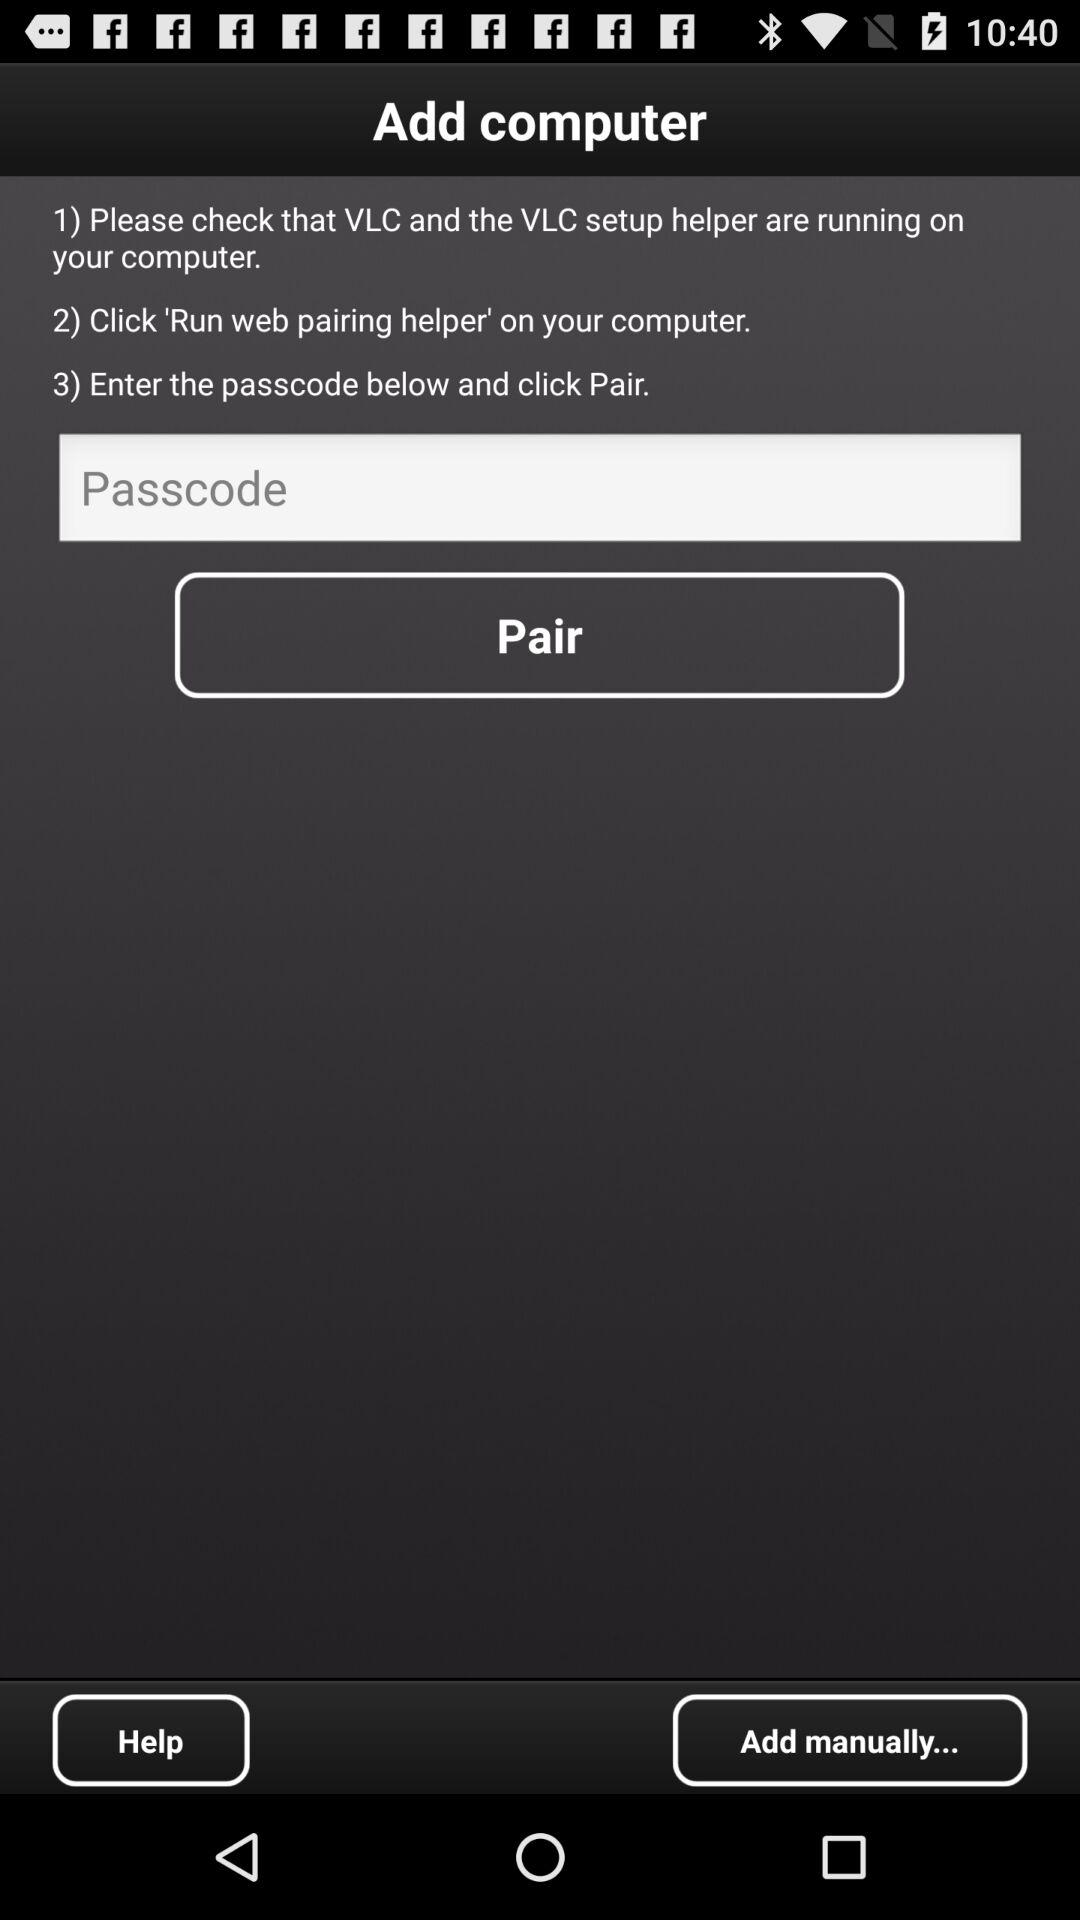How many steps are there in the instructions?
Answer the question using a single word or phrase. 3 